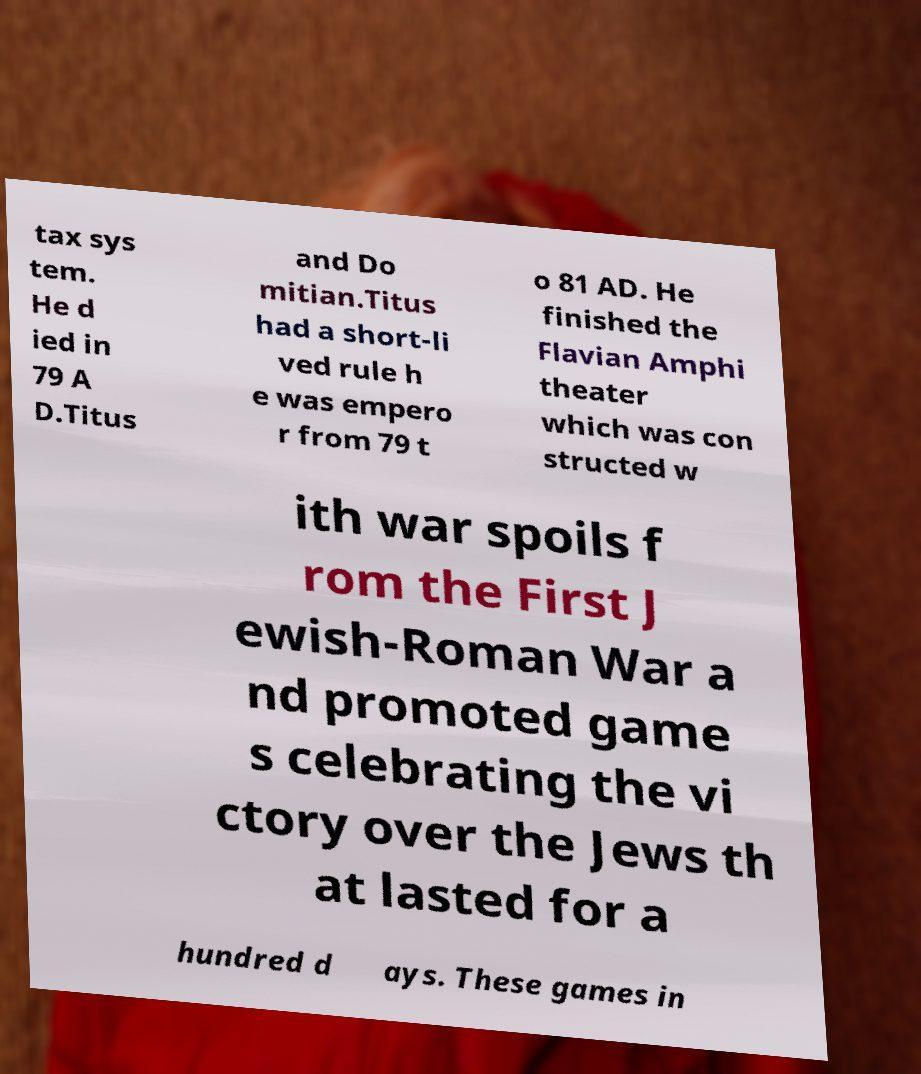There's text embedded in this image that I need extracted. Can you transcribe it verbatim? tax sys tem. He d ied in 79 A D.Titus and Do mitian.Titus had a short-li ved rule h e was empero r from 79 t o 81 AD. He finished the Flavian Amphi theater which was con structed w ith war spoils f rom the First J ewish-Roman War a nd promoted game s celebrating the vi ctory over the Jews th at lasted for a hundred d ays. These games in 